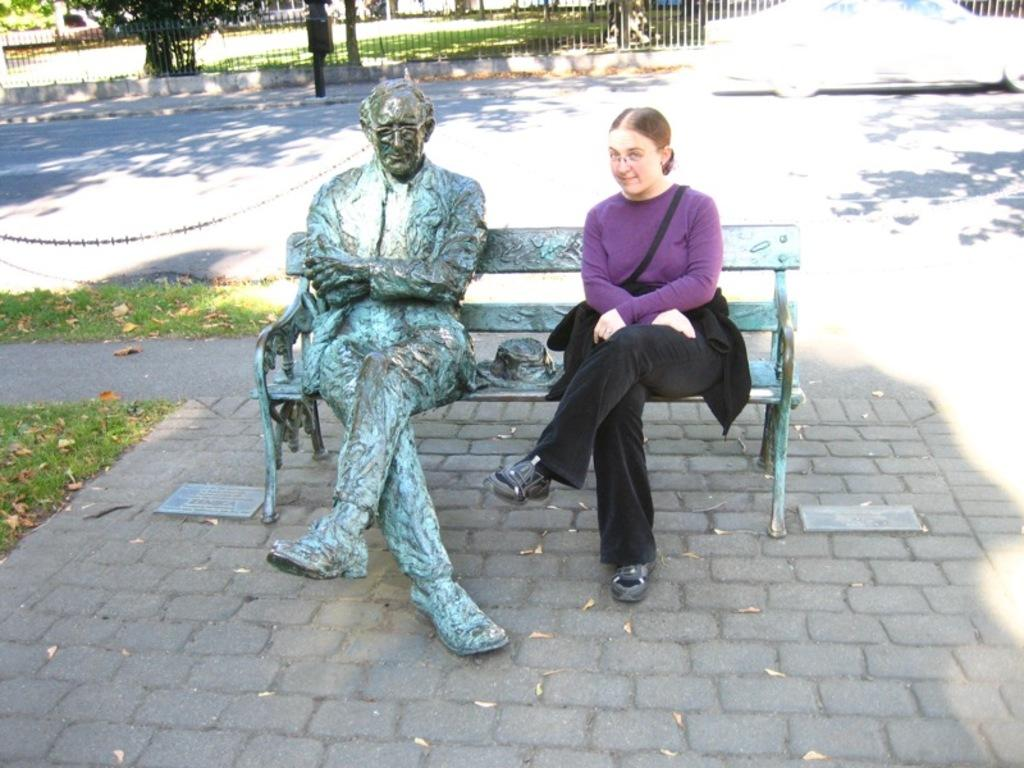What type of seating is visible in the image? There is a bench in the image. What is on the bench? There is a statue on the bench. Who is sitting on the bench? A person is sitting on the bench beside the statue. What can be seen on the road in the image? There is a car on the road in the image. What is in the background of the image? There is railing and trees in the background of the image. What is the texture of the answer in the image? There is no answer present in the image, so it is not possible to determine its texture. 